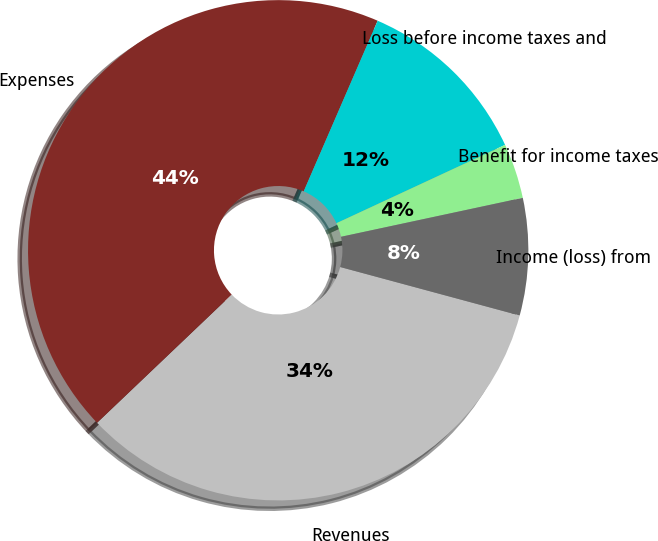<chart> <loc_0><loc_0><loc_500><loc_500><pie_chart><fcel>Revenues<fcel>Expenses<fcel>Loss before income taxes and<fcel>Benefit for income taxes<fcel>Income (loss) from<nl><fcel>33.69%<fcel>43.62%<fcel>11.57%<fcel>3.56%<fcel>7.56%<nl></chart> 